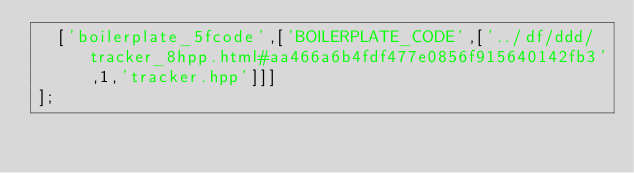Convert code to text. <code><loc_0><loc_0><loc_500><loc_500><_JavaScript_>  ['boilerplate_5fcode',['BOILERPLATE_CODE',['../df/ddd/tracker_8hpp.html#aa466a6b4fdf477e0856f915640142fb3',1,'tracker.hpp']]]
];
</code> 